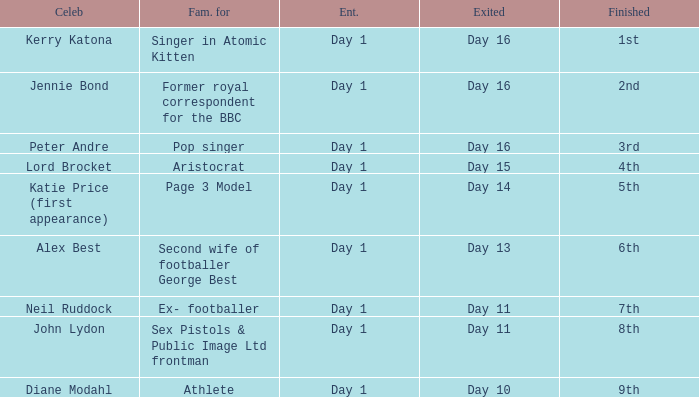Name the finished for exited of day 13 6th. Give me the full table as a dictionary. {'header': ['Celeb', 'Fam. for', 'Ent.', 'Exited', 'Finished'], 'rows': [['Kerry Katona', 'Singer in Atomic Kitten', 'Day 1', 'Day 16', '1st'], ['Jennie Bond', 'Former royal correspondent for the BBC', 'Day 1', 'Day 16', '2nd'], ['Peter Andre', 'Pop singer', 'Day 1', 'Day 16', '3rd'], ['Lord Brocket', 'Aristocrat', 'Day 1', 'Day 15', '4th'], ['Katie Price (first appearance)', 'Page 3 Model', 'Day 1', 'Day 14', '5th'], ['Alex Best', 'Second wife of footballer George Best', 'Day 1', 'Day 13', '6th'], ['Neil Ruddock', 'Ex- footballer', 'Day 1', 'Day 11', '7th'], ['John Lydon', 'Sex Pistols & Public Image Ltd frontman', 'Day 1', 'Day 11', '8th'], ['Diane Modahl', 'Athlete', 'Day 1', 'Day 10', '9th']]} 